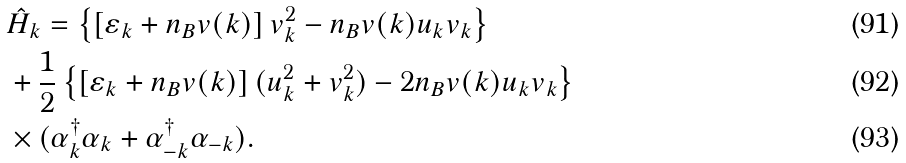<formula> <loc_0><loc_0><loc_500><loc_500>& \hat { H } _ { k } = \left \{ \left [ \varepsilon _ { k } + n _ { B } v ( { k } ) \right ] v _ { k } ^ { 2 } - n _ { B } v ( { k } ) u _ { k } v _ { k } \right \} \\ & + \frac { 1 } { 2 } \left \{ \left [ \varepsilon _ { k } + n _ { B } v ( { k } ) \right ] ( u _ { k } ^ { 2 } + v _ { k } ^ { 2 } ) - 2 n _ { B } v ( { k } ) u _ { k } v _ { k } \right \} \\ & \times ( \alpha _ { k } ^ { \dagger } \alpha _ { k } + \alpha _ { - k } ^ { \dagger } \alpha _ { - k } ) .</formula> 